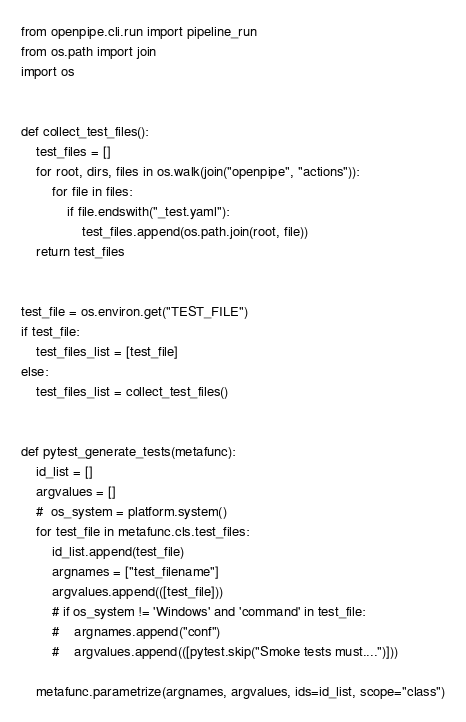Convert code to text. <code><loc_0><loc_0><loc_500><loc_500><_Python_>from openpipe.cli.run import pipeline_run
from os.path import join
import os


def collect_test_files():
    test_files = []
    for root, dirs, files in os.walk(join("openpipe", "actions")):
        for file in files:
            if file.endswith("_test.yaml"):
                test_files.append(os.path.join(root, file))
    return test_files


test_file = os.environ.get("TEST_FILE")
if test_file:
    test_files_list = [test_file]
else:
    test_files_list = collect_test_files()


def pytest_generate_tests(metafunc):
    id_list = []
    argvalues = []
    #  os_system = platform.system()
    for test_file in metafunc.cls.test_files:
        id_list.append(test_file)
        argnames = ["test_filename"]
        argvalues.append(([test_file]))
        # if os_system != 'Windows' and 'command' in test_file:
        #    argnames.append("conf")
        #    argvalues.append(([pytest.skip("Smoke tests must....")]))

    metafunc.parametrize(argnames, argvalues, ids=id_list, scope="class")

</code> 